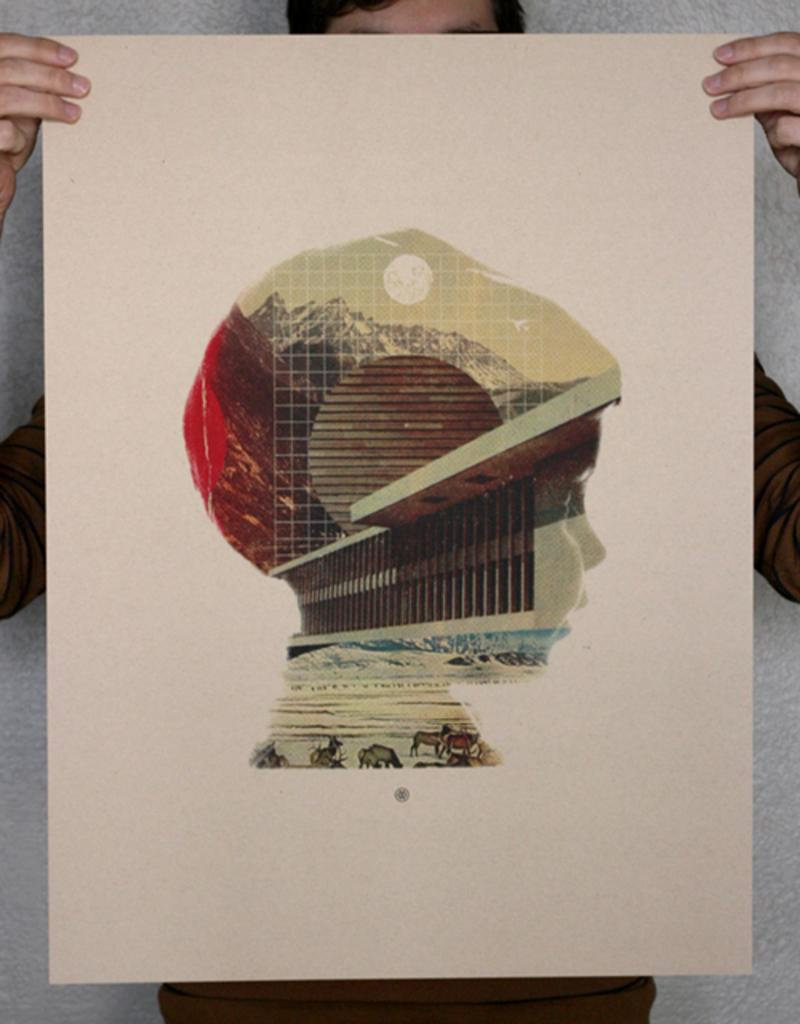Who or what is present in the image? There is a person in the image. What is the person holding in the image? The person is holding a cardboard. Can you describe the cardboard? The cardboard has a graphic image of a boy on it. What is visible behind the person in the image? There is a wall behind the person. What type of yarn is being used to create the graphic image of the boy on the cardboard? There is no yarn present in the image; the graphic image of the boy is printed on the cardboard. 